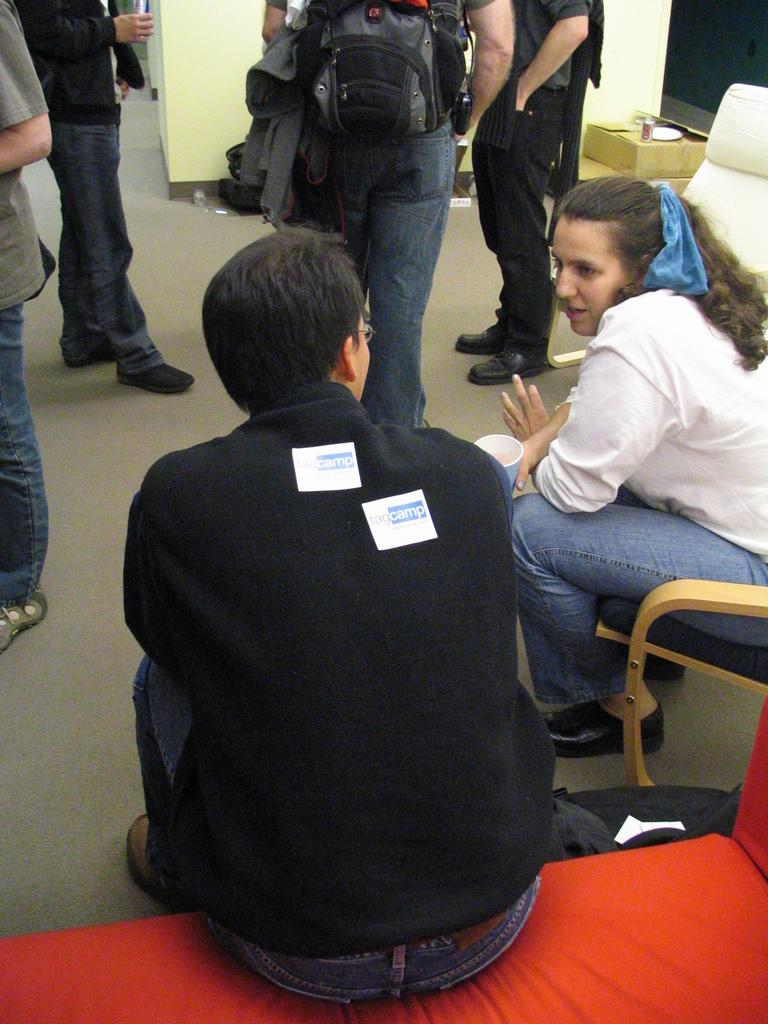What is the man in the image wearing? The man in the image is wearing a black jacket. What is the man doing in the image? The man is sitting. What is the girl in the image wearing? The girl in the image is wearing a white shirt. What is the girl doing in the image? The girl is sitting on a chair. How many people are standing in the image? There are many people standing in the image. What type of steel is used to construct the chairs in the image? There is no information about the chairs or the material they are made of in the image. 